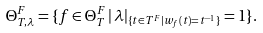Convert formula to latex. <formula><loc_0><loc_0><loc_500><loc_500>\Theta _ { T , \lambda } ^ { F } = \{ f \in \Theta _ { T } ^ { F } \, | \, \lambda | _ { \{ t \in T ^ { F } | w _ { f } ( t ) = t ^ { - 1 } \} } = 1 \} .</formula> 